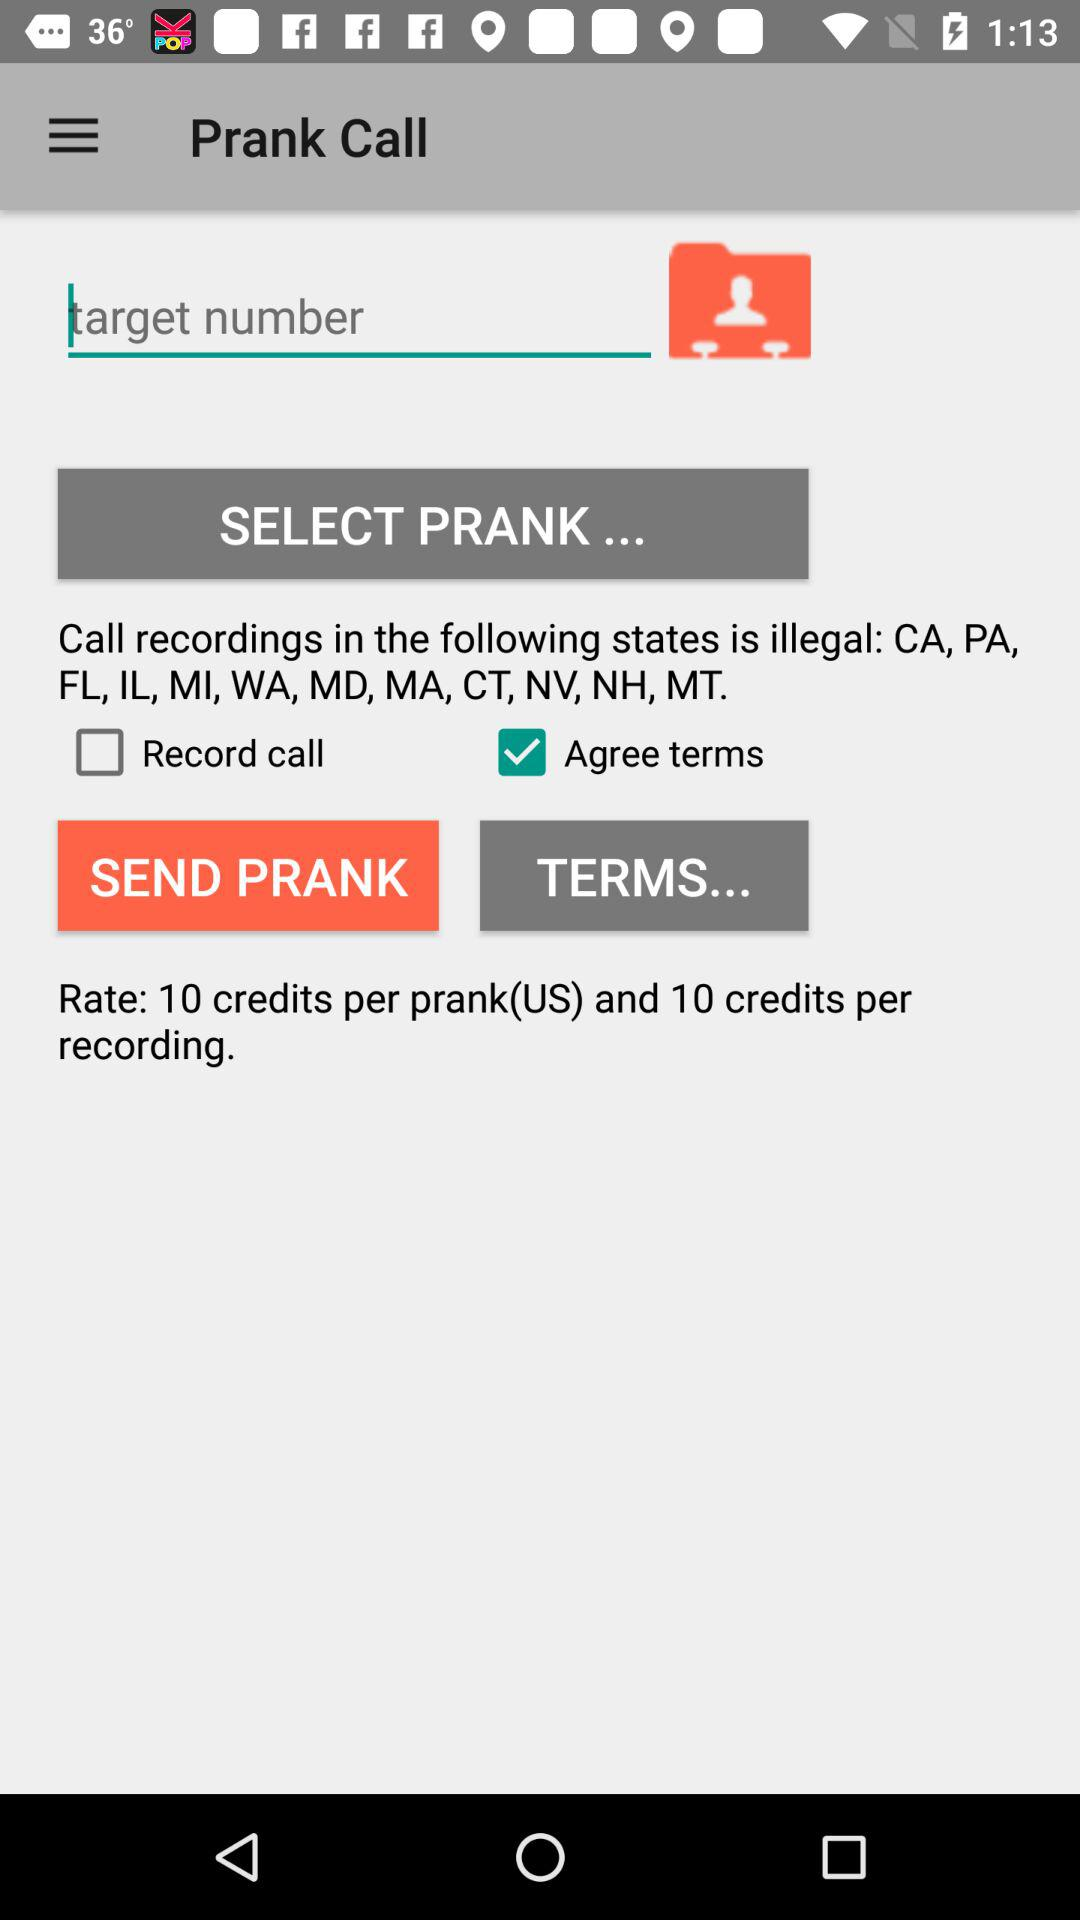How many credits are there per recording? There are 10 credits per recording. 